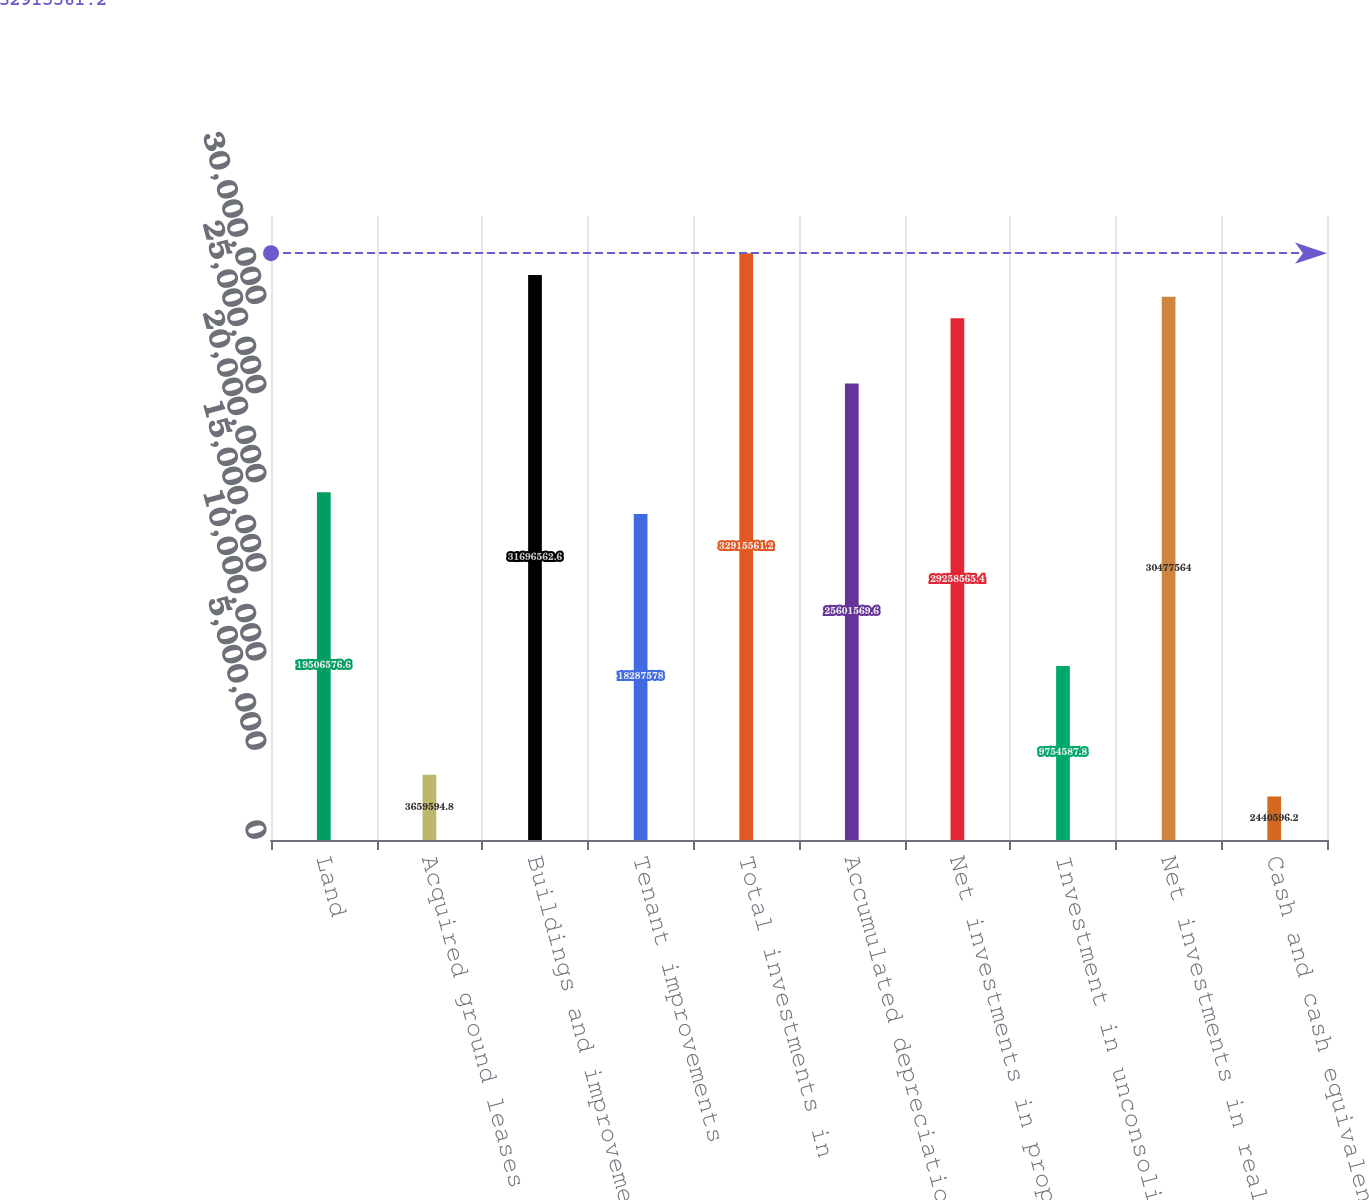Convert chart. <chart><loc_0><loc_0><loc_500><loc_500><bar_chart><fcel>Land<fcel>Acquired ground leases<fcel>Buildings and improvements<fcel>Tenant improvements<fcel>Total investments in<fcel>Accumulated depreciation and<fcel>Net investments in properties<fcel>Investment in unconsolidated<fcel>Net investments in real estate<fcel>Cash and cash equivalents<nl><fcel>1.95066e+07<fcel>3.65959e+06<fcel>3.16966e+07<fcel>1.82876e+07<fcel>3.29156e+07<fcel>2.56016e+07<fcel>2.92586e+07<fcel>9.75459e+06<fcel>3.04776e+07<fcel>2.4406e+06<nl></chart> 